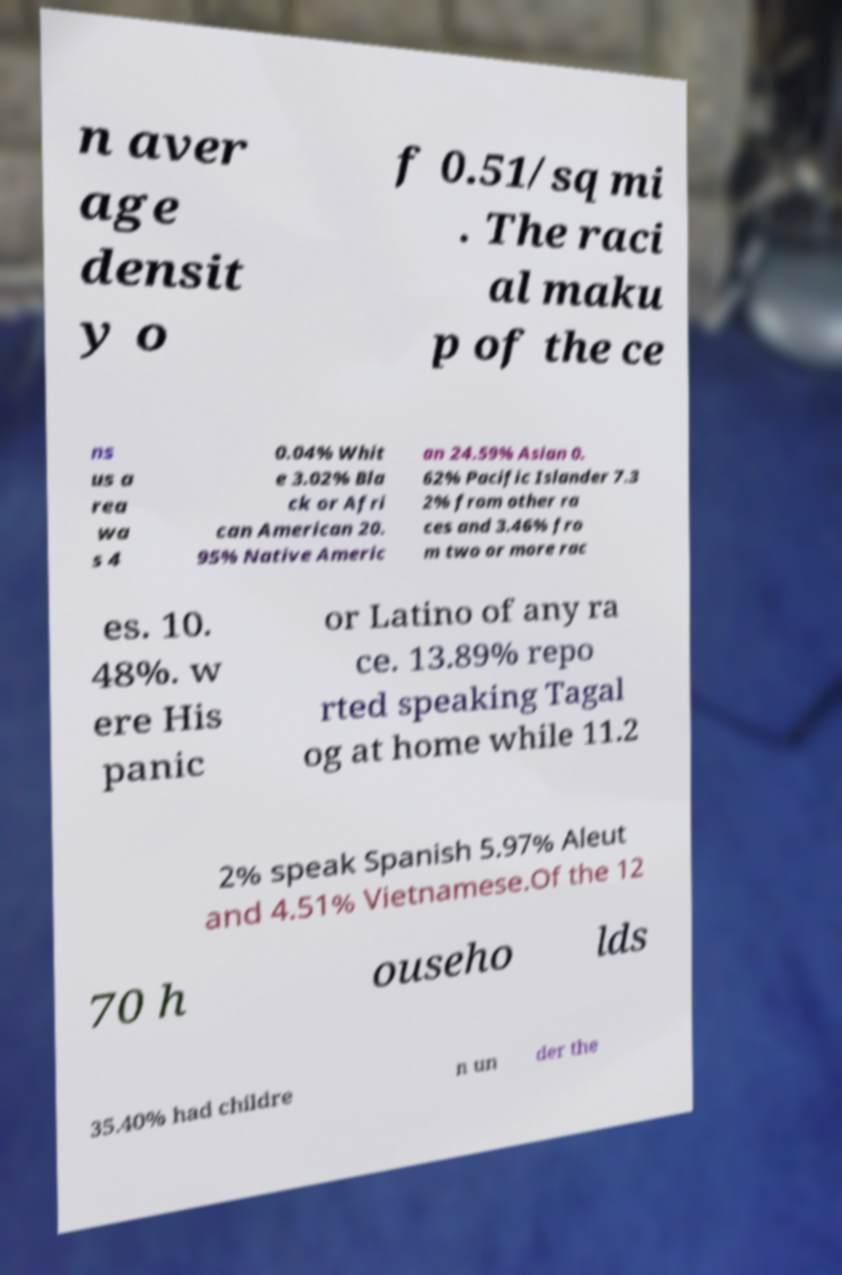Could you extract and type out the text from this image? n aver age densit y o f 0.51/sq mi . The raci al maku p of the ce ns us a rea wa s 4 0.04% Whit e 3.02% Bla ck or Afri can American 20. 95% Native Americ an 24.59% Asian 0. 62% Pacific Islander 7.3 2% from other ra ces and 3.46% fro m two or more rac es. 10. 48%. w ere His panic or Latino of any ra ce. 13.89% repo rted speaking Tagal og at home while 11.2 2% speak Spanish 5.97% Aleut and 4.51% Vietnamese.Of the 12 70 h ouseho lds 35.40% had childre n un der the 